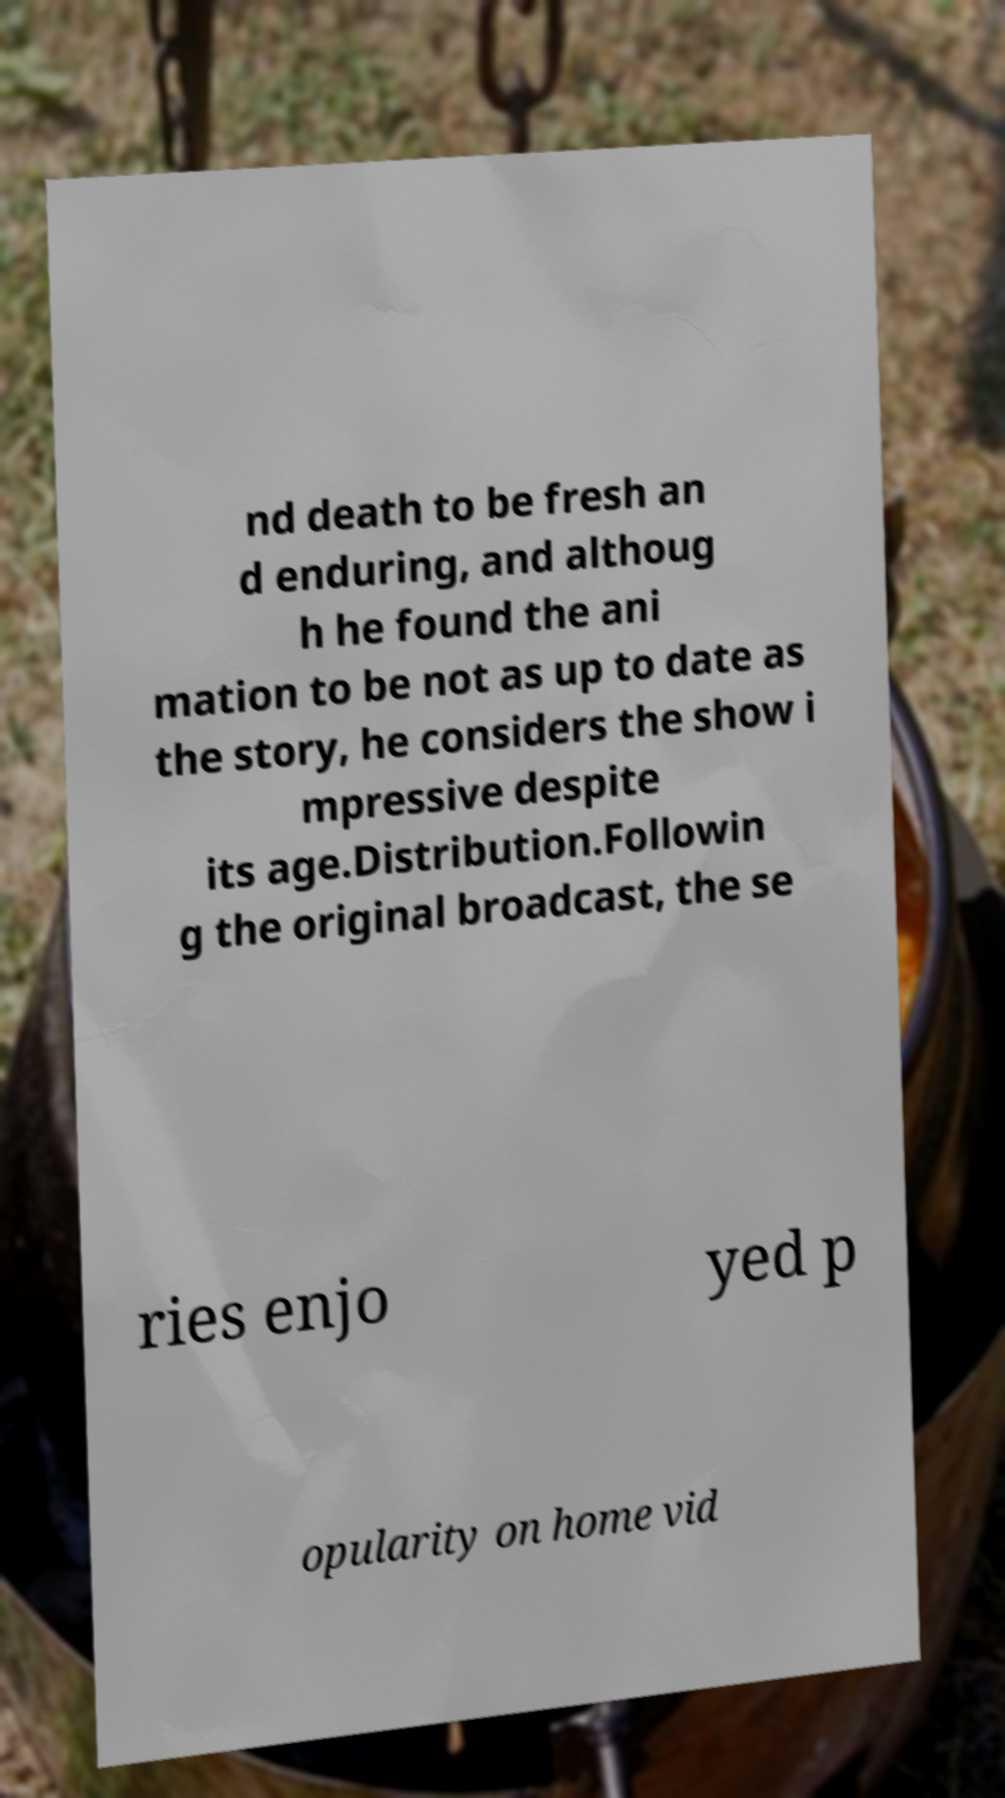I need the written content from this picture converted into text. Can you do that? nd death to be fresh an d enduring, and althoug h he found the ani mation to be not as up to date as the story, he considers the show i mpressive despite its age.Distribution.Followin g the original broadcast, the se ries enjo yed p opularity on home vid 